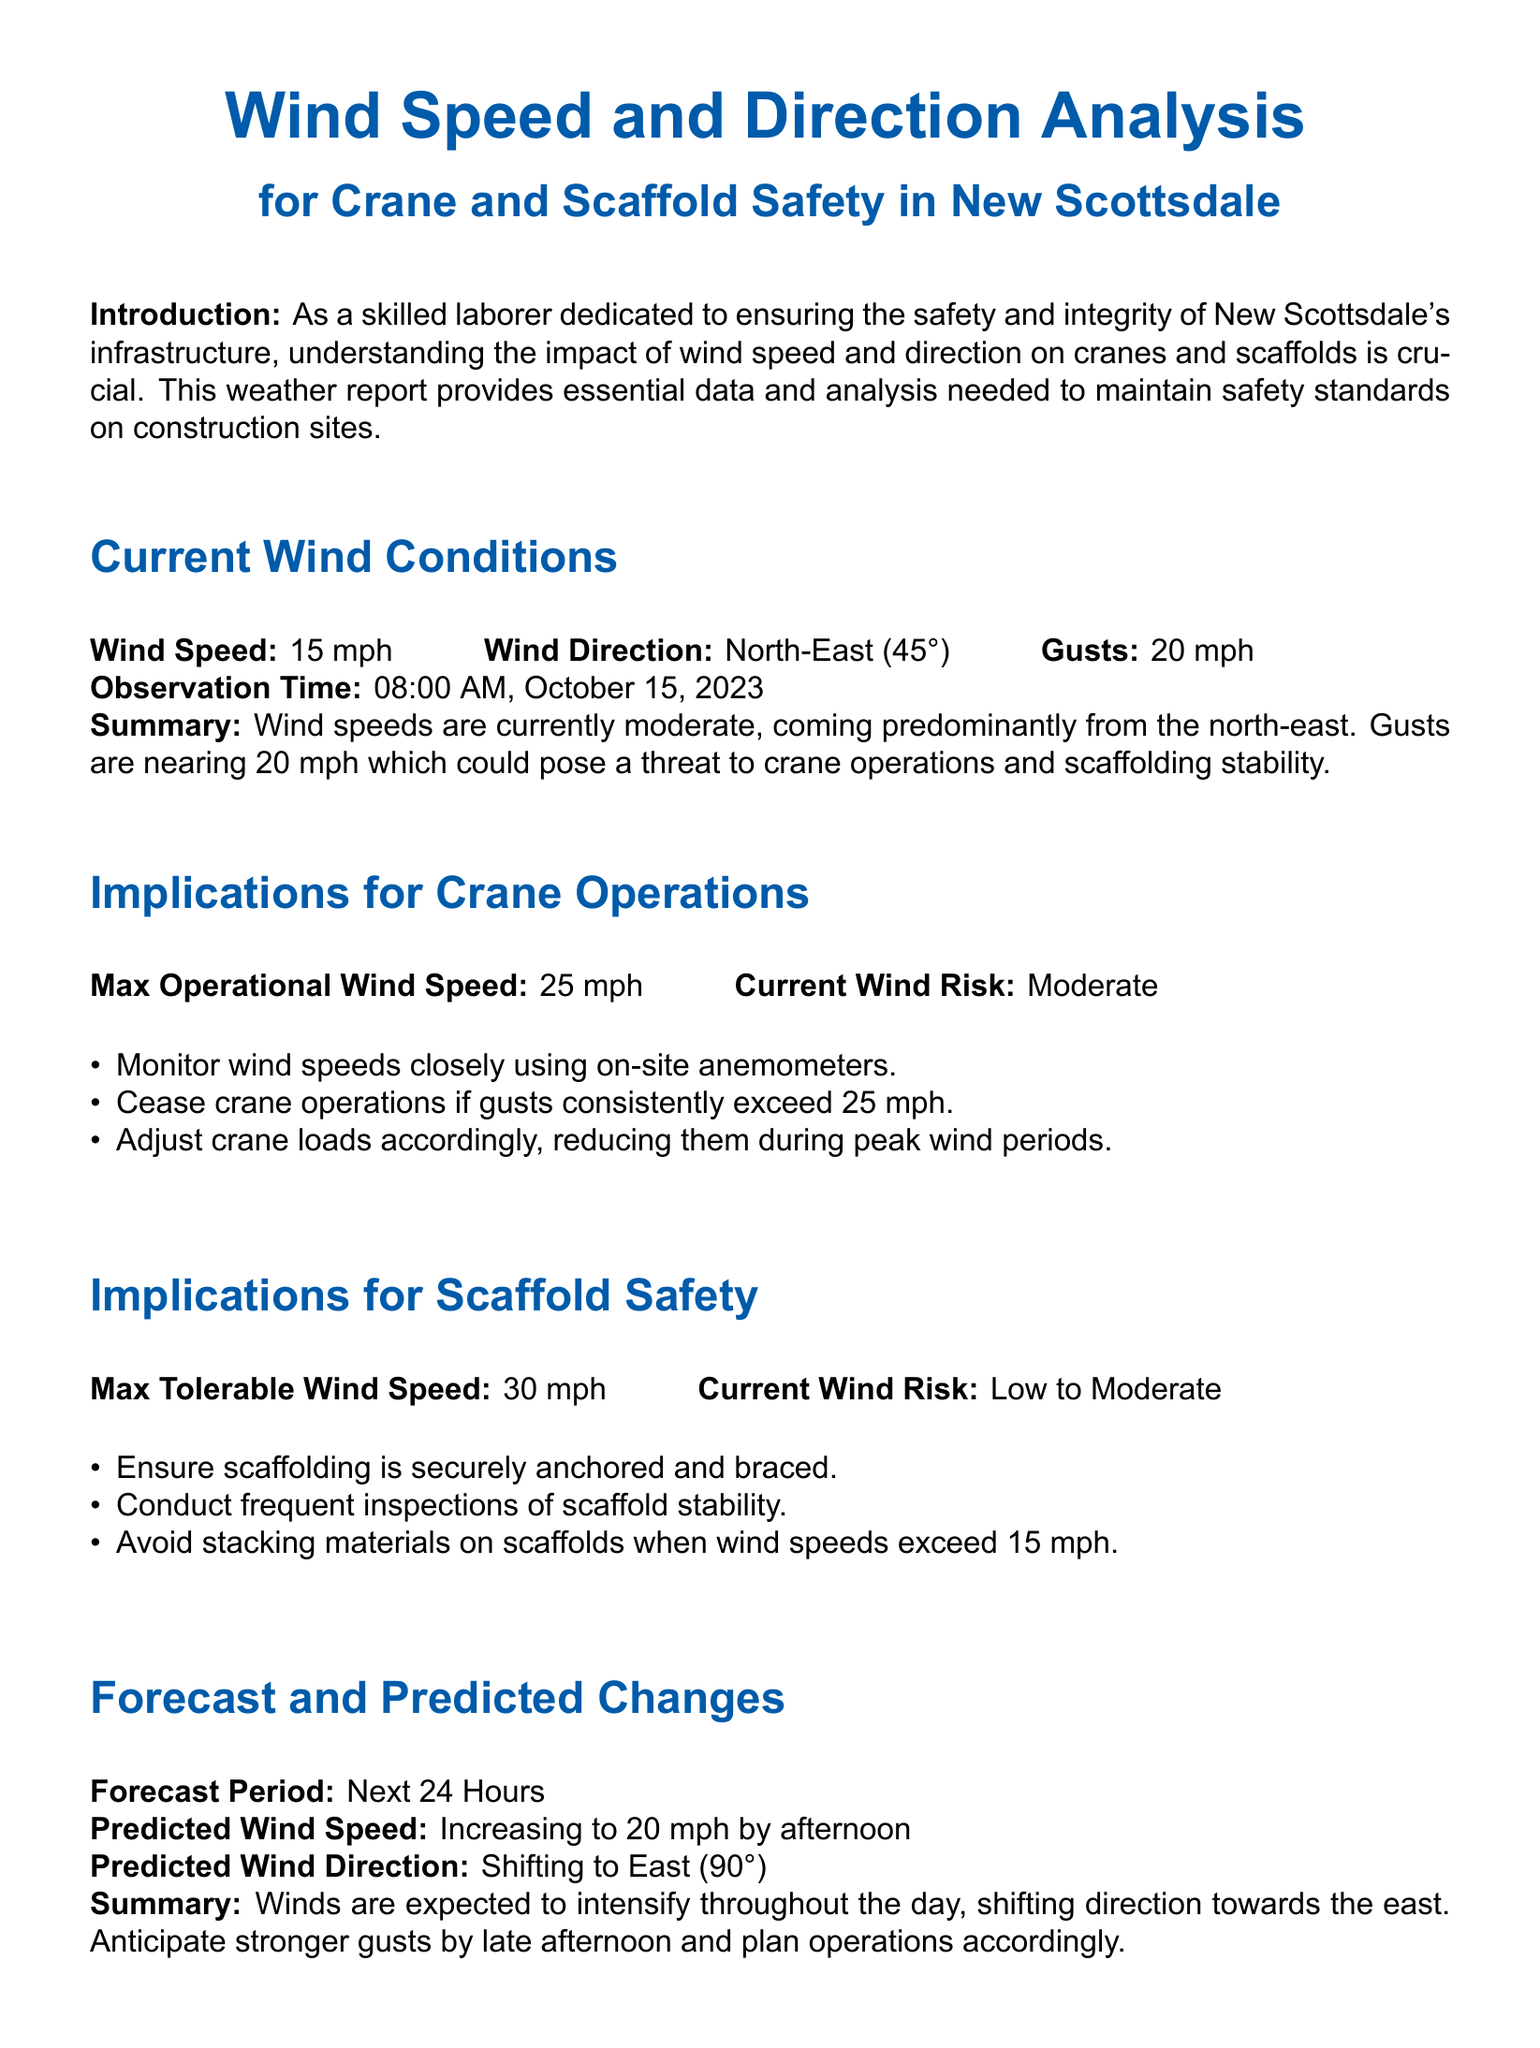What is the current wind speed? The current wind speed is directly stated in the document as 15 mph.
Answer: 15 mph What is the wind direction at 08:00 AM? The document specifies the wind direction at 08:00 AM as North-East (45°).
Answer: North-East (45°) What is the max operational wind speed for crane operations? The max operational wind speed for crane operations is highlighted as 25 mph in the implications section.
Answer: 25 mph What is the predicted wind speed by afternoon? The forecast section indicates that the predicted wind speed will increase to 20 mph by afternoon.
Answer: 20 mph What must personnel wear according to safety protocols? The safety protocols section states that all personnel must wear appropriate safety harnesses.
Answer: Safety harnesses What is the current wind risk for crane operations? The document describes the current wind risk for crane operations as Moderate.
Answer: Moderate What should be avoided on scaffolds when wind speeds exceed 15 mph? The implications for scaffold safety section advises to avoid stacking materials on scaffolds when wind speeds exceed 15 mph.
Answer: Stacking materials What is the emergency contact for the Safety Manager? The document lists the Safety Manager's contact as John Wilkins at 555-123-4567.
Answer: John Wilkins (555-123-4567) What is the weather condition as of the document's observation time? The summary of current wind conditions describes the weather condition as moderate winds predominantly from the North-East.
Answer: Moderate winds What are the gusts reaching up to? The report notes that gusts are reaching up to 20 mph.
Answer: 20 mph 